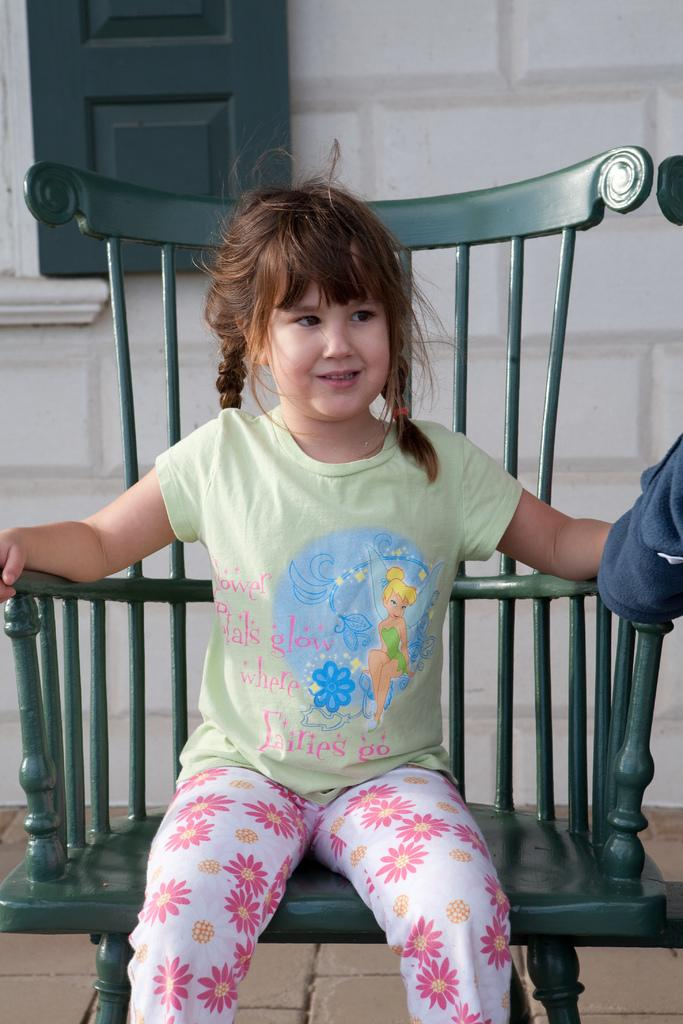What is the person in the image doing? There is a person sitting on a chair in the image. What is the person wearing? The person is wearing a colorful dress. What can be seen in the background of the image? There is a white wall and a window in the background of the image. What type of value can be seen in the image? There is no value present in the image; it features a person sitting on a chair wearing a colorful dress, with a white wall and a window in the background. How many units are visible in the image? There is no unit present in the image; it features a person sitting on a chair wearing a colorful dress, with a white wall and a window in the background. 